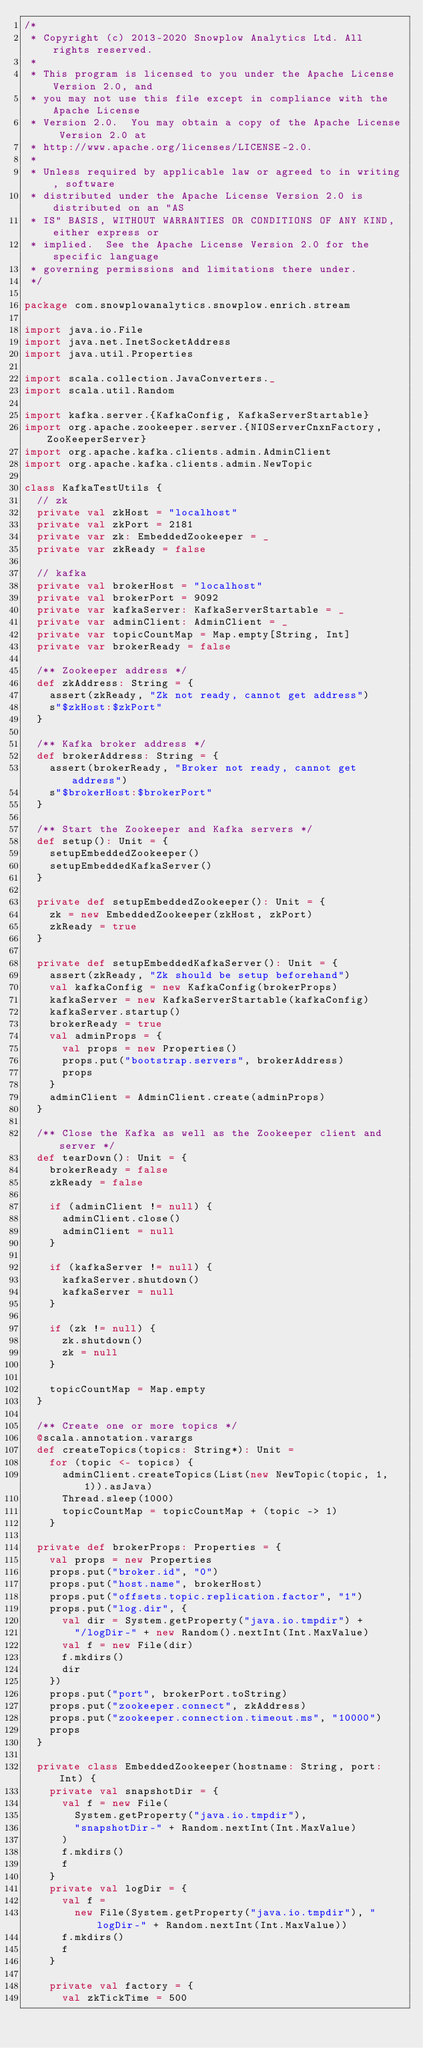<code> <loc_0><loc_0><loc_500><loc_500><_Scala_>/*
 * Copyright (c) 2013-2020 Snowplow Analytics Ltd. All rights reserved.
 *
 * This program is licensed to you under the Apache License Version 2.0, and
 * you may not use this file except in compliance with the Apache License
 * Version 2.0.  You may obtain a copy of the Apache License Version 2.0 at
 * http://www.apache.org/licenses/LICENSE-2.0.
 *
 * Unless required by applicable law or agreed to in writing, software
 * distributed under the Apache License Version 2.0 is distributed on an "AS
 * IS" BASIS, WITHOUT WARRANTIES OR CONDITIONS OF ANY KIND, either express or
 * implied.  See the Apache License Version 2.0 for the specific language
 * governing permissions and limitations there under.
 */

package com.snowplowanalytics.snowplow.enrich.stream

import java.io.File
import java.net.InetSocketAddress
import java.util.Properties

import scala.collection.JavaConverters._
import scala.util.Random

import kafka.server.{KafkaConfig, KafkaServerStartable}
import org.apache.zookeeper.server.{NIOServerCnxnFactory, ZooKeeperServer}
import org.apache.kafka.clients.admin.AdminClient
import org.apache.kafka.clients.admin.NewTopic

class KafkaTestUtils {
  // zk
  private val zkHost = "localhost"
  private val zkPort = 2181
  private var zk: EmbeddedZookeeper = _
  private var zkReady = false

  // kafka
  private val brokerHost = "localhost"
  private val brokerPort = 9092
  private var kafkaServer: KafkaServerStartable = _
  private var adminClient: AdminClient = _
  private var topicCountMap = Map.empty[String, Int]
  private var brokerReady = false

  /** Zookeeper address */
  def zkAddress: String = {
    assert(zkReady, "Zk not ready, cannot get address")
    s"$zkHost:$zkPort"
  }

  /** Kafka broker address */
  def brokerAddress: String = {
    assert(brokerReady, "Broker not ready, cannot get address")
    s"$brokerHost:$brokerPort"
  }

  /** Start the Zookeeper and Kafka servers */
  def setup(): Unit = {
    setupEmbeddedZookeeper()
    setupEmbeddedKafkaServer()
  }

  private def setupEmbeddedZookeeper(): Unit = {
    zk = new EmbeddedZookeeper(zkHost, zkPort)
    zkReady = true
  }

  private def setupEmbeddedKafkaServer(): Unit = {
    assert(zkReady, "Zk should be setup beforehand")
    val kafkaConfig = new KafkaConfig(brokerProps)
    kafkaServer = new KafkaServerStartable(kafkaConfig)
    kafkaServer.startup()
    brokerReady = true
    val adminProps = {
      val props = new Properties()
      props.put("bootstrap.servers", brokerAddress)
      props
    }
    adminClient = AdminClient.create(adminProps)
  }

  /** Close the Kafka as well as the Zookeeper client and server */
  def tearDown(): Unit = {
    brokerReady = false
    zkReady = false

    if (adminClient != null) {
      adminClient.close()
      adminClient = null
    }

    if (kafkaServer != null) {
      kafkaServer.shutdown()
      kafkaServer = null
    }

    if (zk != null) {
      zk.shutdown()
      zk = null
    }

    topicCountMap = Map.empty
  }

  /** Create one or more topics */
  @scala.annotation.varargs
  def createTopics(topics: String*): Unit =
    for (topic <- topics) {
      adminClient.createTopics(List(new NewTopic(topic, 1, 1)).asJava)
      Thread.sleep(1000)
      topicCountMap = topicCountMap + (topic -> 1)
    }

  private def brokerProps: Properties = {
    val props = new Properties
    props.put("broker.id", "0")
    props.put("host.name", brokerHost)
    props.put("offsets.topic.replication.factor", "1")
    props.put("log.dir", {
      val dir = System.getProperty("java.io.tmpdir") +
        "/logDir-" + new Random().nextInt(Int.MaxValue)
      val f = new File(dir)
      f.mkdirs()
      dir
    })
    props.put("port", brokerPort.toString)
    props.put("zookeeper.connect", zkAddress)
    props.put("zookeeper.connection.timeout.ms", "10000")
    props
  }

  private class EmbeddedZookeeper(hostname: String, port: Int) {
    private val snapshotDir = {
      val f = new File(
        System.getProperty("java.io.tmpdir"),
        "snapshotDir-" + Random.nextInt(Int.MaxValue)
      )
      f.mkdirs()
      f
    }
    private val logDir = {
      val f =
        new File(System.getProperty("java.io.tmpdir"), "logDir-" + Random.nextInt(Int.MaxValue))
      f.mkdirs()
      f
    }

    private val factory = {
      val zkTickTime = 500</code> 